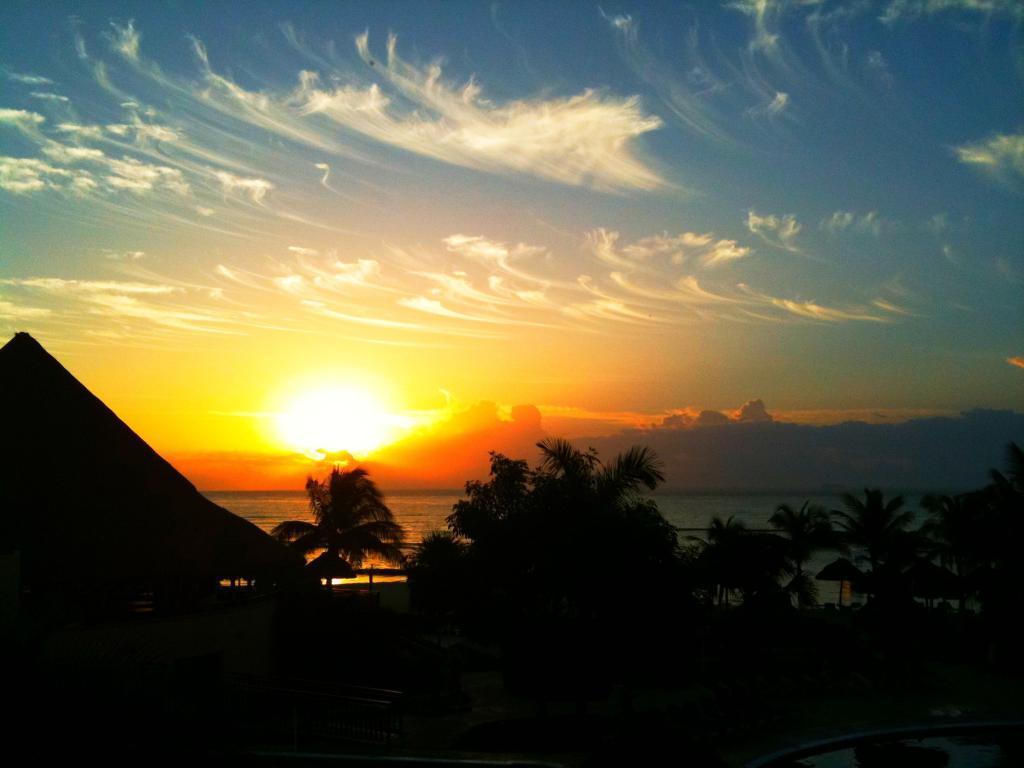Could you give a brief overview of what you see in this image? Here in this picture we can see trees present all over there and beside that on the left side we can see a hut present and we can see a sun set in the sky and we can see clouds in the sky. 